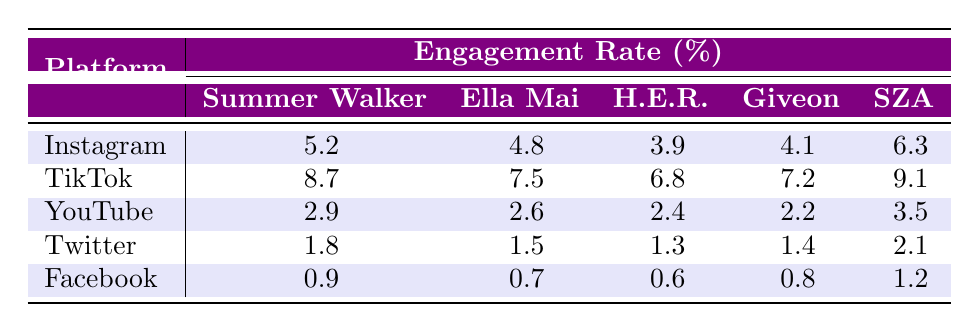What is SZA's engagement rate on TikTok? From the TikTok row, SZA's engagement rate is listed as 9.1.
Answer: 9.1 Which platform shows the highest engagement rate for Giveon? By looking at the engagement rates for Giveon across all platforms, TikTok has the highest at 7.2.
Answer: 7.2 True or False: H.E.R. has a higher engagement rate on Instagram than on YouTube. Checking the engagement rates, H.E.R. has 3.9% on Instagram and 2.4% on YouTube, which means this statement is true.
Answer: True What is the difference in engagement rates for Summer Walker between Instagram and Facebook? Summer Walker's engagement rate is 5.2% on Instagram and 0.9% on Facebook. The difference is 5.2 - 0.9 = 4.3%.
Answer: 4.3 What is the average engagement rate on Twitter across all five artists? The engagement rates on Twitter for the five artists are 1.8, 1.5, 1.3, 1.4, and 2.1. The sum is 1.8 + 1.5 + 1.3 + 1.4 + 2.1 = 8.1 and dividing by 5 gives an average of 8.1 / 5 = 1.62.
Answer: 1.62 Which artist has the lowest engagement rate on YouTube? Looking at the YouTube row, Giveon has the lowest engagement rate of 2.2%.
Answer: 2.2 Is Ella Mai's engagement rate on Instagram higher than her engagement rate on Twitter? Ella Mai has an engagement rate of 4.8% on Instagram and 1.5% on Twitter, making this statement true.
Answer: True What is the total engagement rate for SZA across all platforms? SZA's engagement rates are 6.3% on Instagram, 9.1% on TikTok, 3.5% on YouTube, 2.1% on Twitter, and 1.2% on Facebook. The total is 6.3 + 9.1 + 3.5 + 2.1 + 1.2 = 22.2%.
Answer: 22.2 